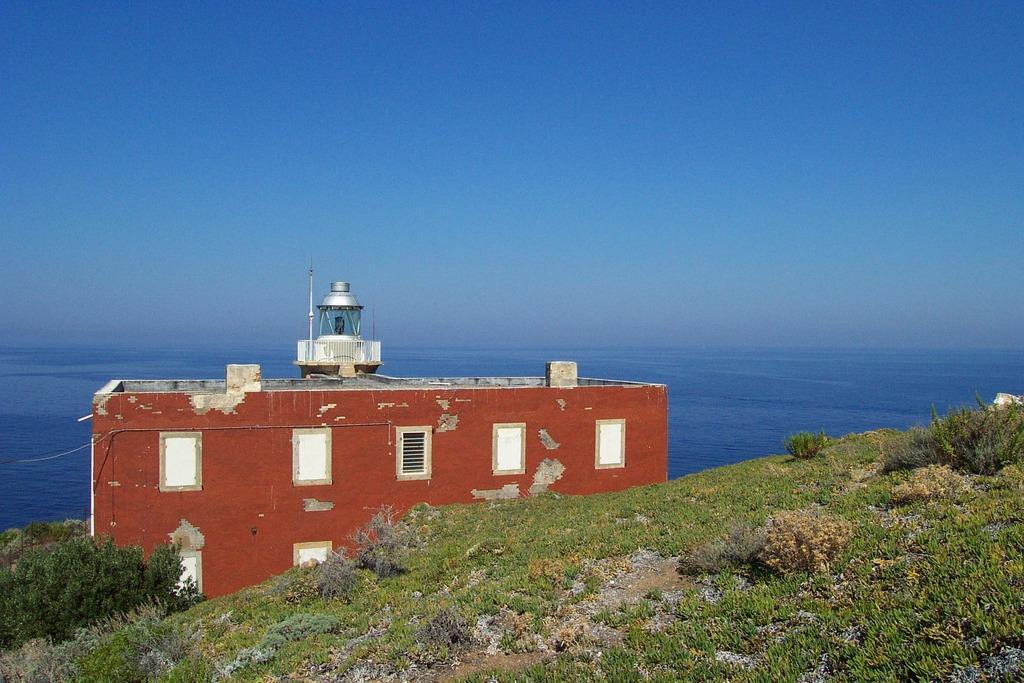In one or two sentences, can you explain what this image depicts? In the center of the image there is building. At the bottom of the image there is grass. In the background of the image there is water. 